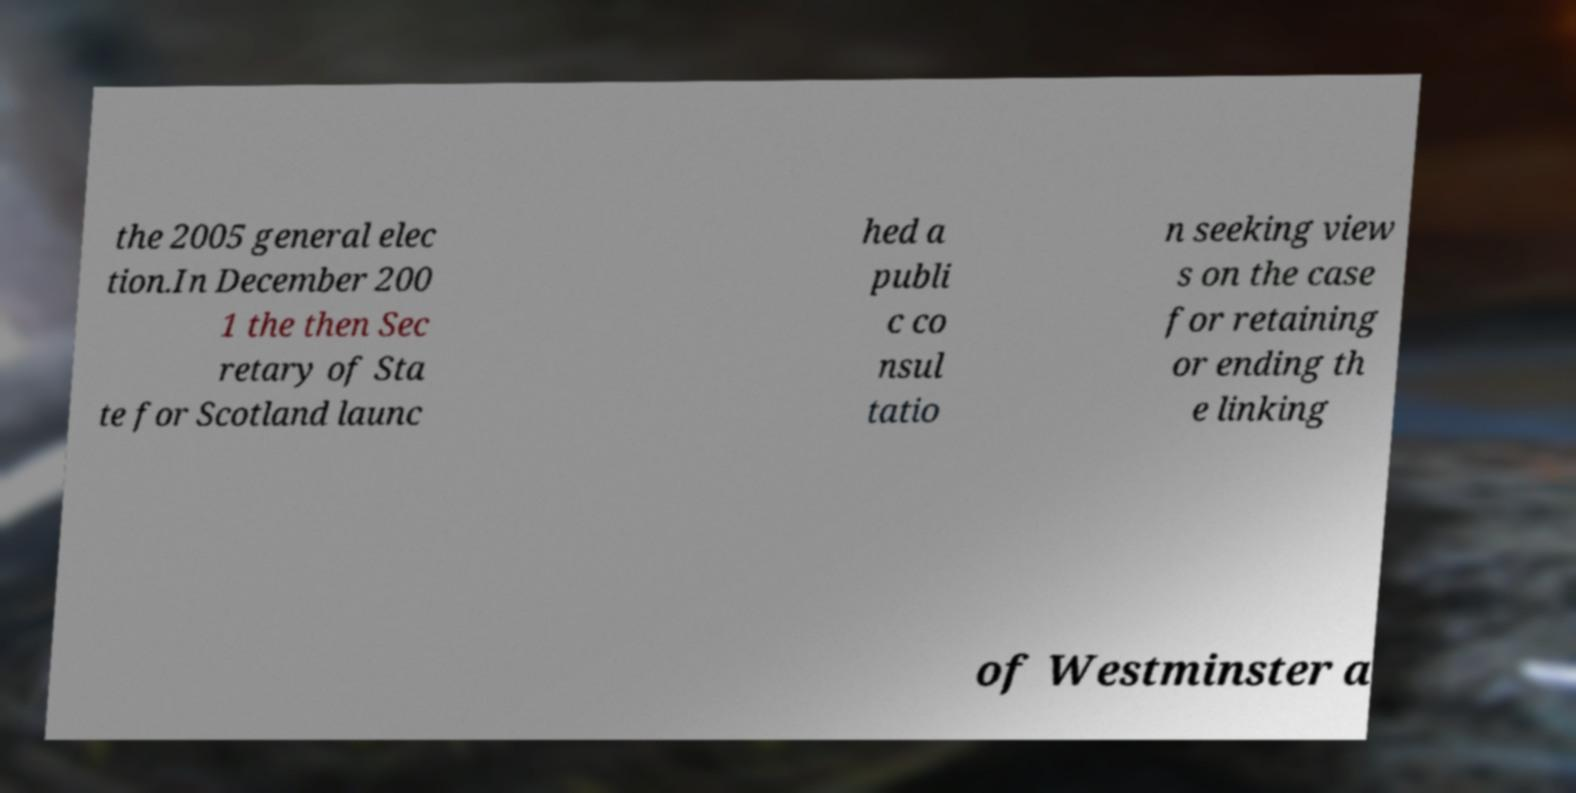What messages or text are displayed in this image? I need them in a readable, typed format. the 2005 general elec tion.In December 200 1 the then Sec retary of Sta te for Scotland launc hed a publi c co nsul tatio n seeking view s on the case for retaining or ending th e linking of Westminster a 